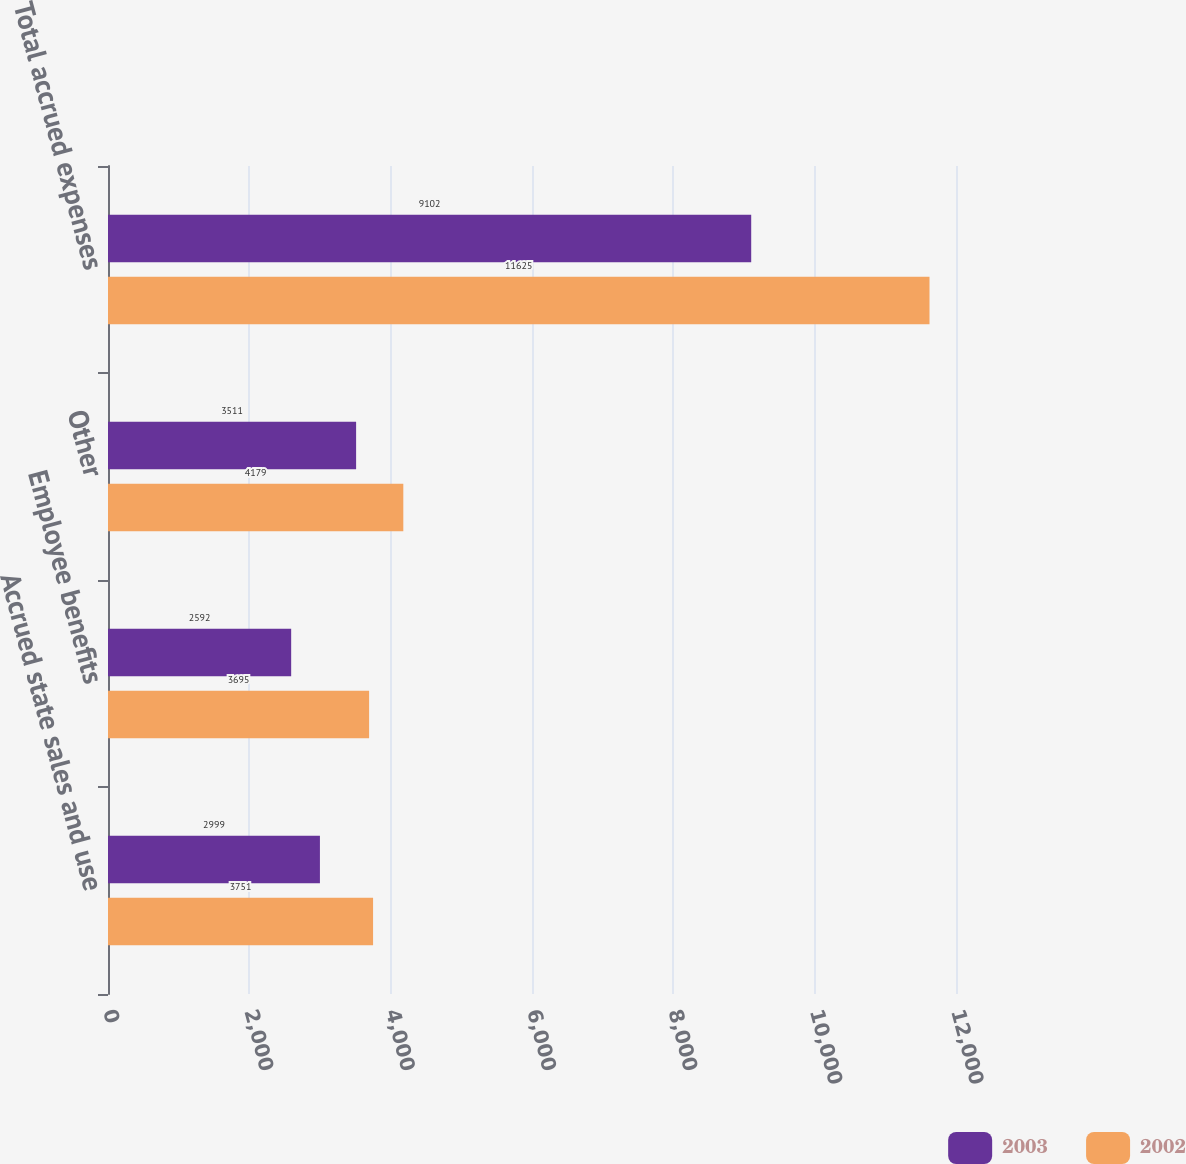<chart> <loc_0><loc_0><loc_500><loc_500><stacked_bar_chart><ecel><fcel>Accrued state sales and use<fcel>Employee benefits<fcel>Other<fcel>Total accrued expenses<nl><fcel>2003<fcel>2999<fcel>2592<fcel>3511<fcel>9102<nl><fcel>2002<fcel>3751<fcel>3695<fcel>4179<fcel>11625<nl></chart> 